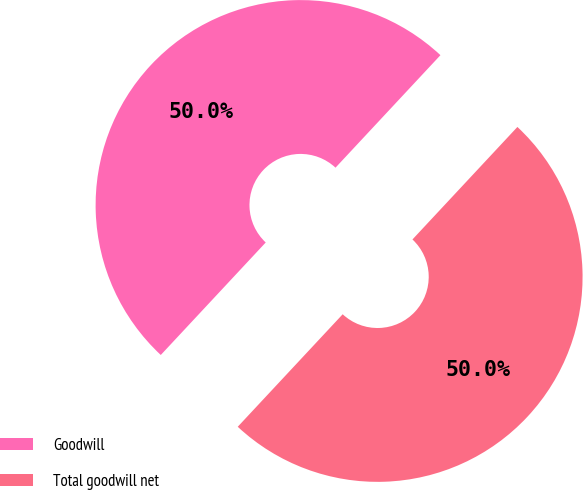<chart> <loc_0><loc_0><loc_500><loc_500><pie_chart><fcel>Goodwill<fcel>Total goodwill net<nl><fcel>50.0%<fcel>50.0%<nl></chart> 